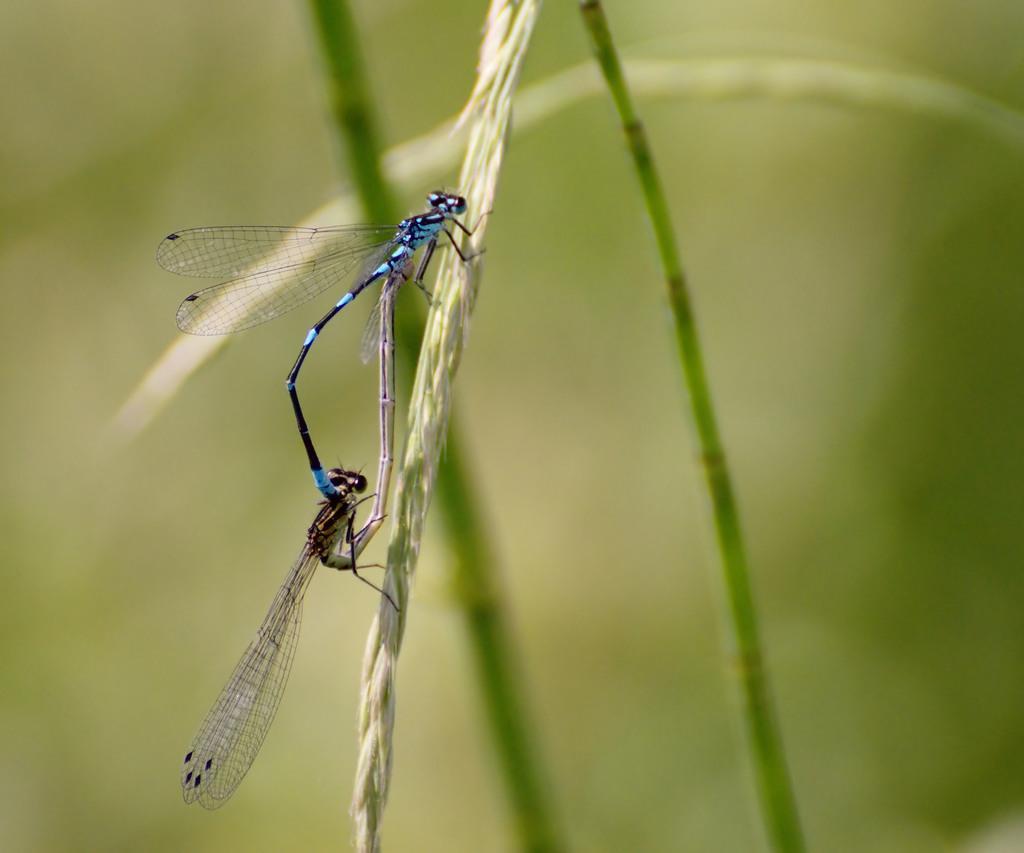How would you summarize this image in a sentence or two? In this picture I can see couple of Dragonflies on the plant and they are blue and black in color. 